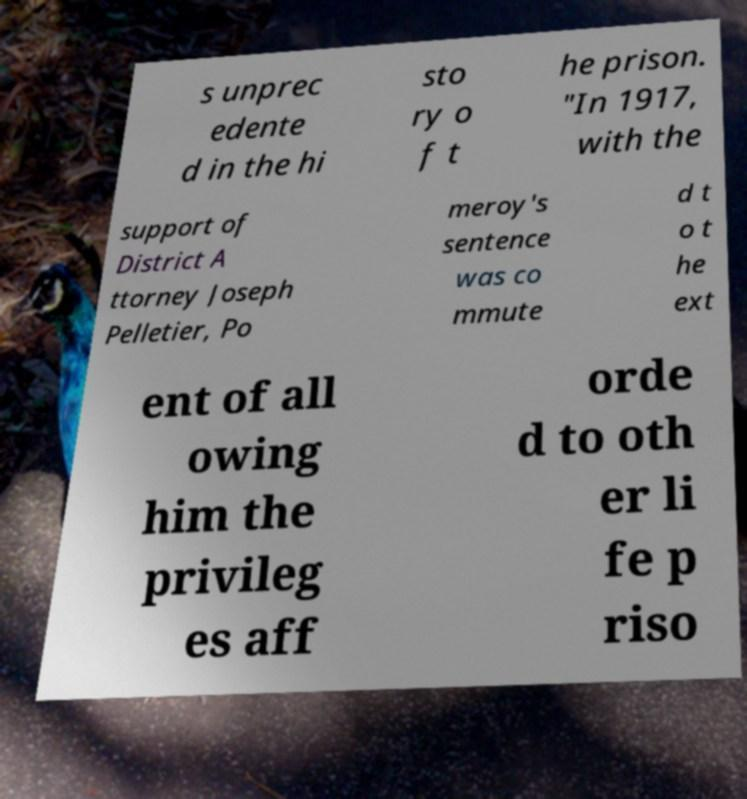For documentation purposes, I need the text within this image transcribed. Could you provide that? s unprec edente d in the hi sto ry o f t he prison. "In 1917, with the support of District A ttorney Joseph Pelletier, Po meroy's sentence was co mmute d t o t he ext ent of all owing him the privileg es aff orde d to oth er li fe p riso 